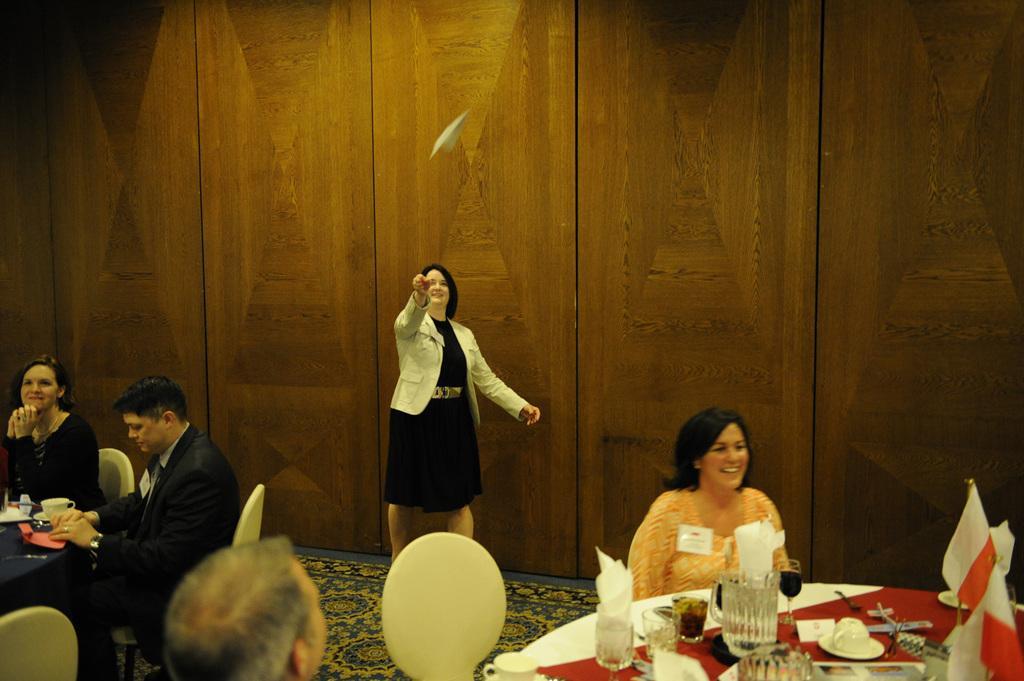Describe this image in one or two sentences. People are sitting in chairs at tables. There is woman throwing paper plane in the background. 